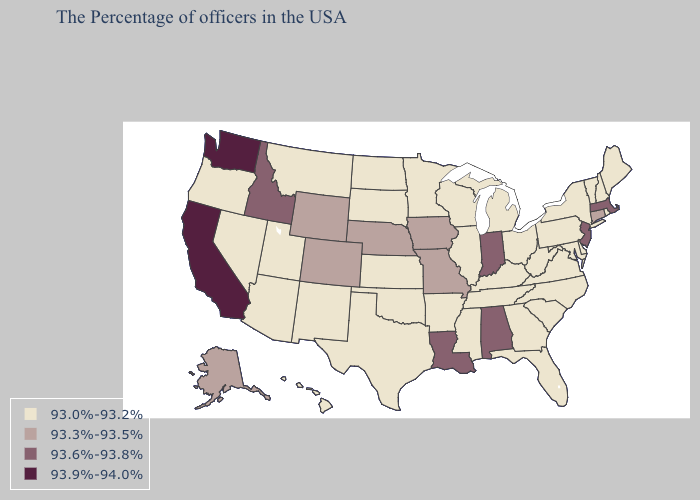Name the states that have a value in the range 93.9%-94.0%?
Concise answer only. California, Washington. Does Vermont have the highest value in the Northeast?
Be succinct. No. Name the states that have a value in the range 93.0%-93.2%?
Be succinct. Maine, Rhode Island, New Hampshire, Vermont, New York, Delaware, Maryland, Pennsylvania, Virginia, North Carolina, South Carolina, West Virginia, Ohio, Florida, Georgia, Michigan, Kentucky, Tennessee, Wisconsin, Illinois, Mississippi, Arkansas, Minnesota, Kansas, Oklahoma, Texas, South Dakota, North Dakota, New Mexico, Utah, Montana, Arizona, Nevada, Oregon, Hawaii. Does the map have missing data?
Keep it brief. No. Does Delaware have a higher value than Michigan?
Give a very brief answer. No. What is the value of Utah?
Give a very brief answer. 93.0%-93.2%. Name the states that have a value in the range 93.3%-93.5%?
Short answer required. Connecticut, Missouri, Iowa, Nebraska, Wyoming, Colorado, Alaska. What is the highest value in states that border Virginia?
Keep it brief. 93.0%-93.2%. Name the states that have a value in the range 93.9%-94.0%?
Short answer required. California, Washington. How many symbols are there in the legend?
Keep it brief. 4. Name the states that have a value in the range 93.6%-93.8%?
Give a very brief answer. Massachusetts, New Jersey, Indiana, Alabama, Louisiana, Idaho. What is the value of Oklahoma?
Write a very short answer. 93.0%-93.2%. What is the value of Oregon?
Short answer required. 93.0%-93.2%. Does Arizona have the same value as South Carolina?
Be succinct. Yes. What is the value of Minnesota?
Write a very short answer. 93.0%-93.2%. 